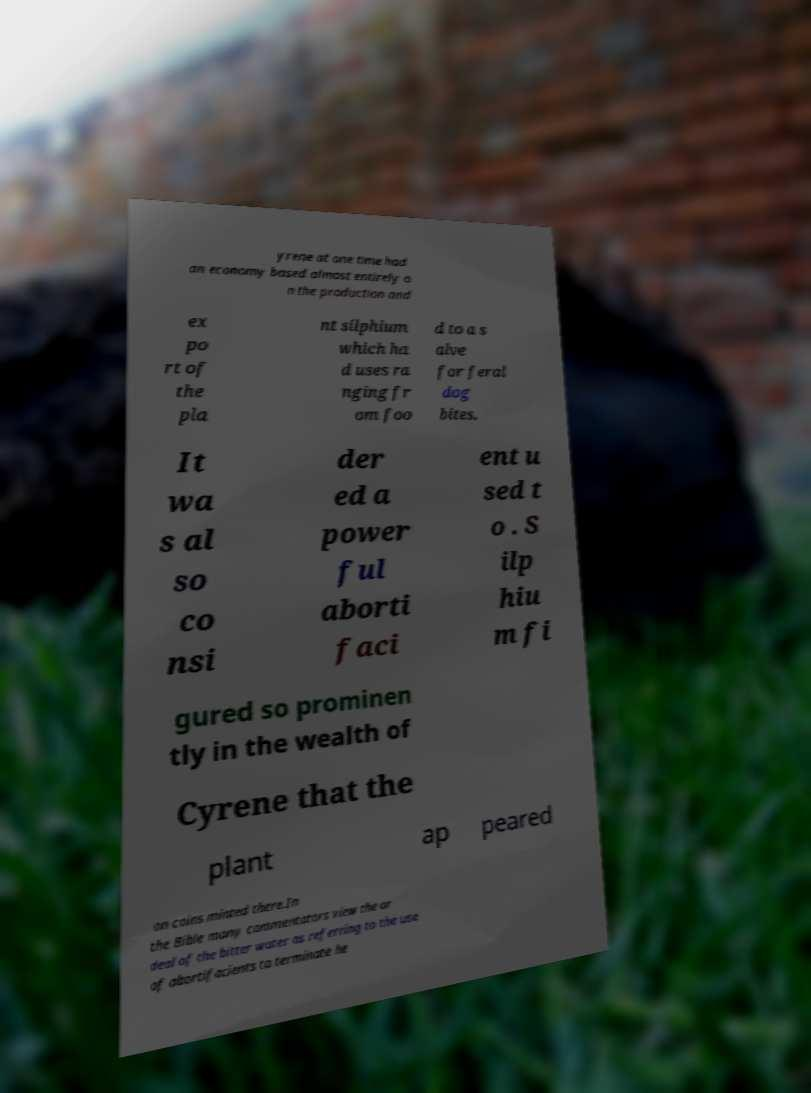Could you assist in decoding the text presented in this image and type it out clearly? yrene at one time had an economy based almost entirely o n the production and ex po rt of the pla nt silphium which ha d uses ra nging fr om foo d to a s alve for feral dog bites. It wa s al so co nsi der ed a power ful aborti faci ent u sed t o . S ilp hiu m fi gured so prominen tly in the wealth of Cyrene that the plant ap peared on coins minted there.In the Bible many commentators view the or deal of the bitter water as referring to the use of abortifacients to terminate he 